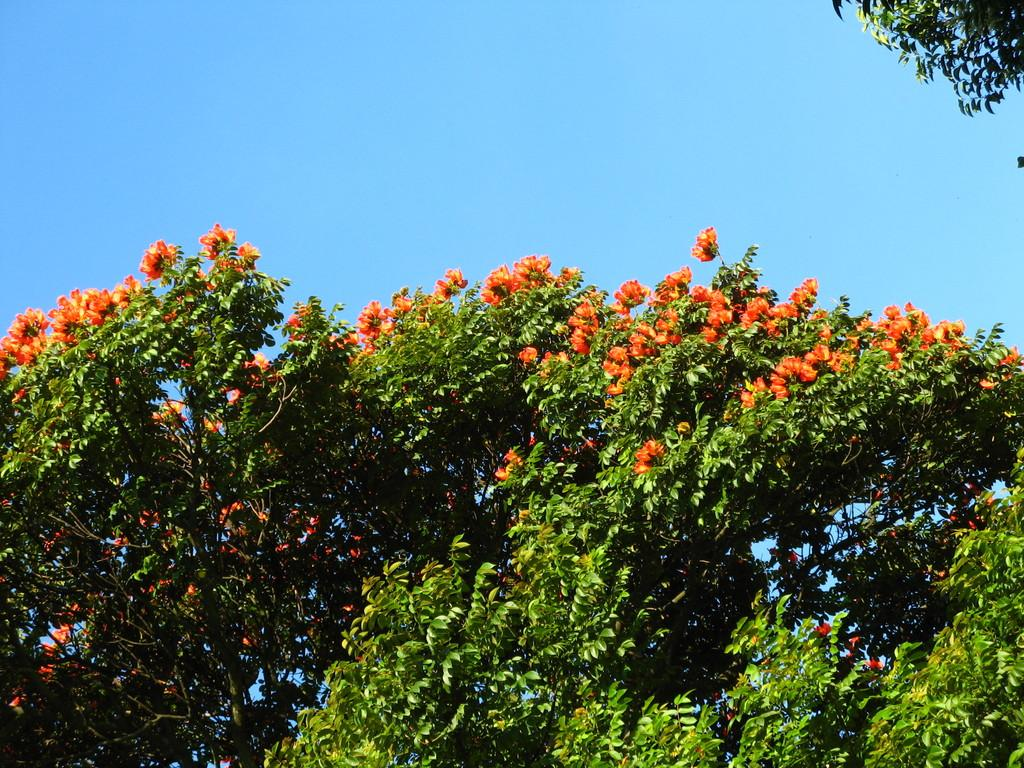What type of vegetation can be seen in the image? There are branches of a tree in the image. What are the branches adorned with? There are beautiful flowers on the branches. What type of bell can be heard ringing in the image? There is no bell present in the image, and therefore no sound can be heard. 